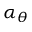Convert formula to latex. <formula><loc_0><loc_0><loc_500><loc_500>\alpha _ { \theta }</formula> 